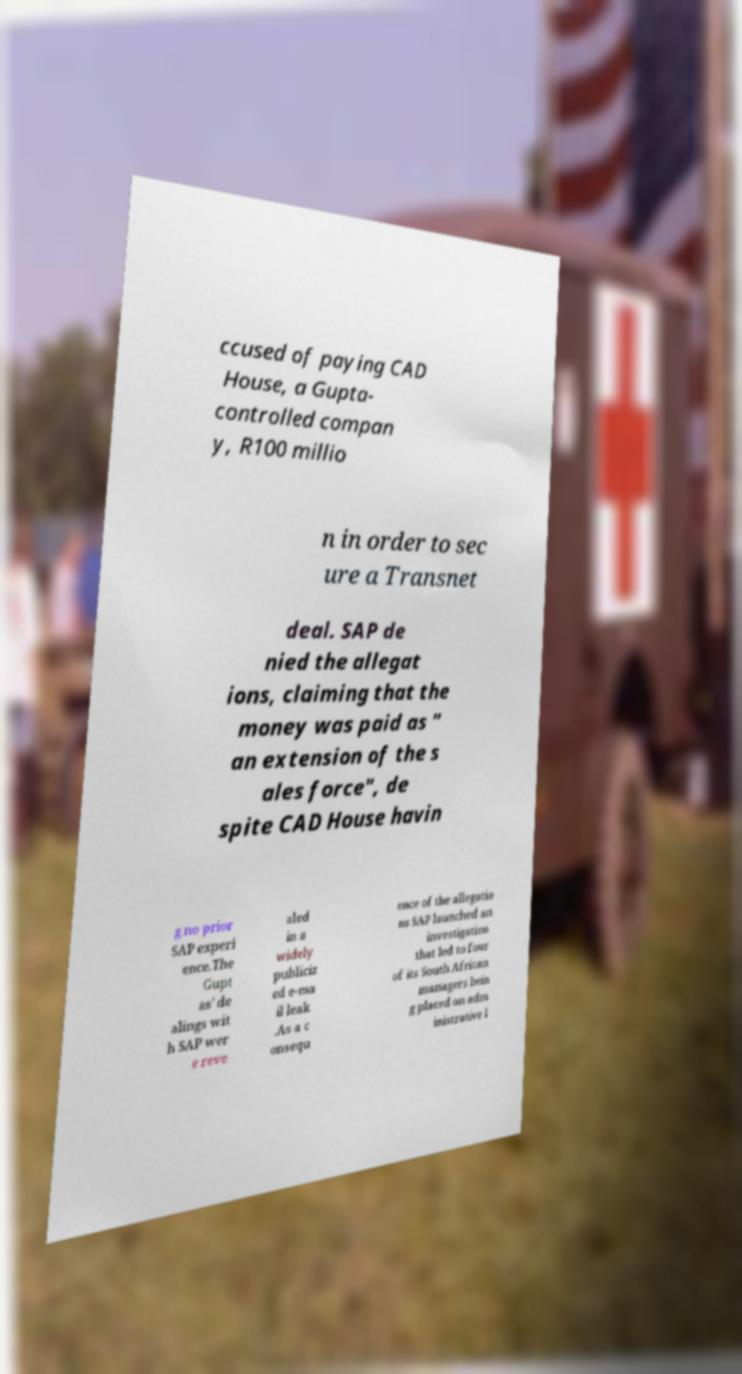For documentation purposes, I need the text within this image transcribed. Could you provide that? ccused of paying CAD House, a Gupta- controlled compan y, R100 millio n in order to sec ure a Transnet deal. SAP de nied the allegat ions, claiming that the money was paid as " an extension of the s ales force", de spite CAD House havin g no prior SAP experi ence.The Gupt as' de alings wit h SAP wer e reve aled in a widely publiciz ed e-ma il leak .As a c onsequ ence of the allegatio ns SAP launched an investigation that led to four of its South African managers bein g placed on adm inistrative l 